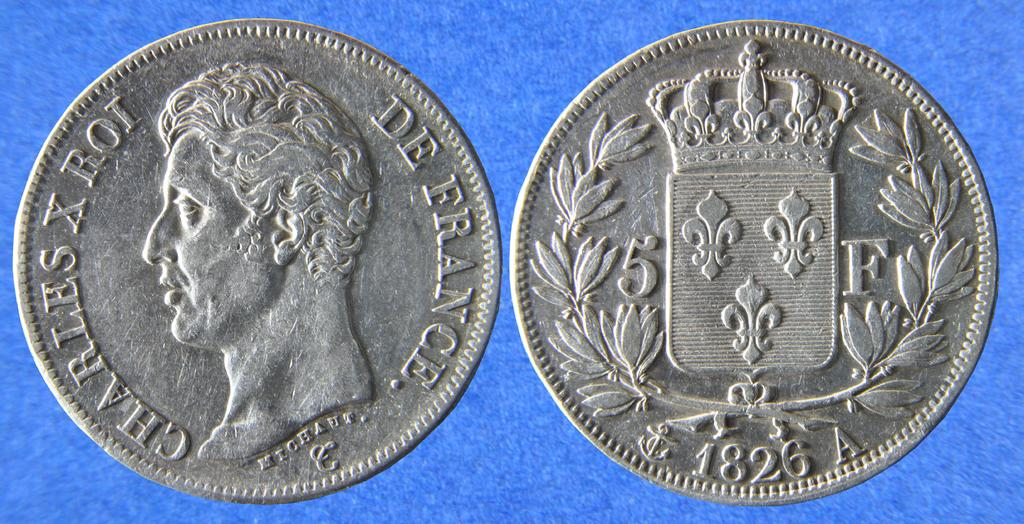<image>
Describe the image concisely. a silver coin that says 'charles x rot' on it 